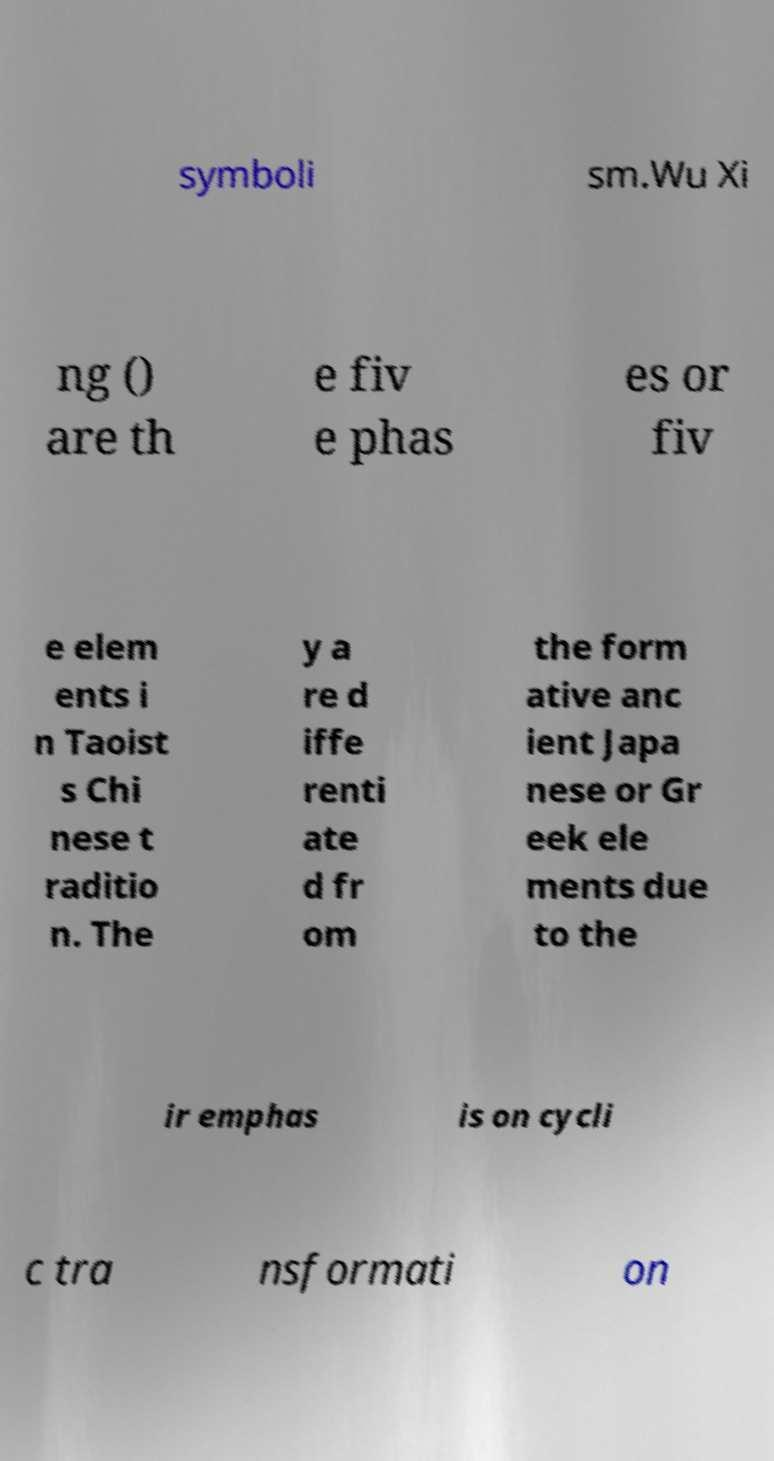There's text embedded in this image that I need extracted. Can you transcribe it verbatim? symboli sm.Wu Xi ng () are th e fiv e phas es or fiv e elem ents i n Taoist s Chi nese t raditio n. The y a re d iffe renti ate d fr om the form ative anc ient Japa nese or Gr eek ele ments due to the ir emphas is on cycli c tra nsformati on 